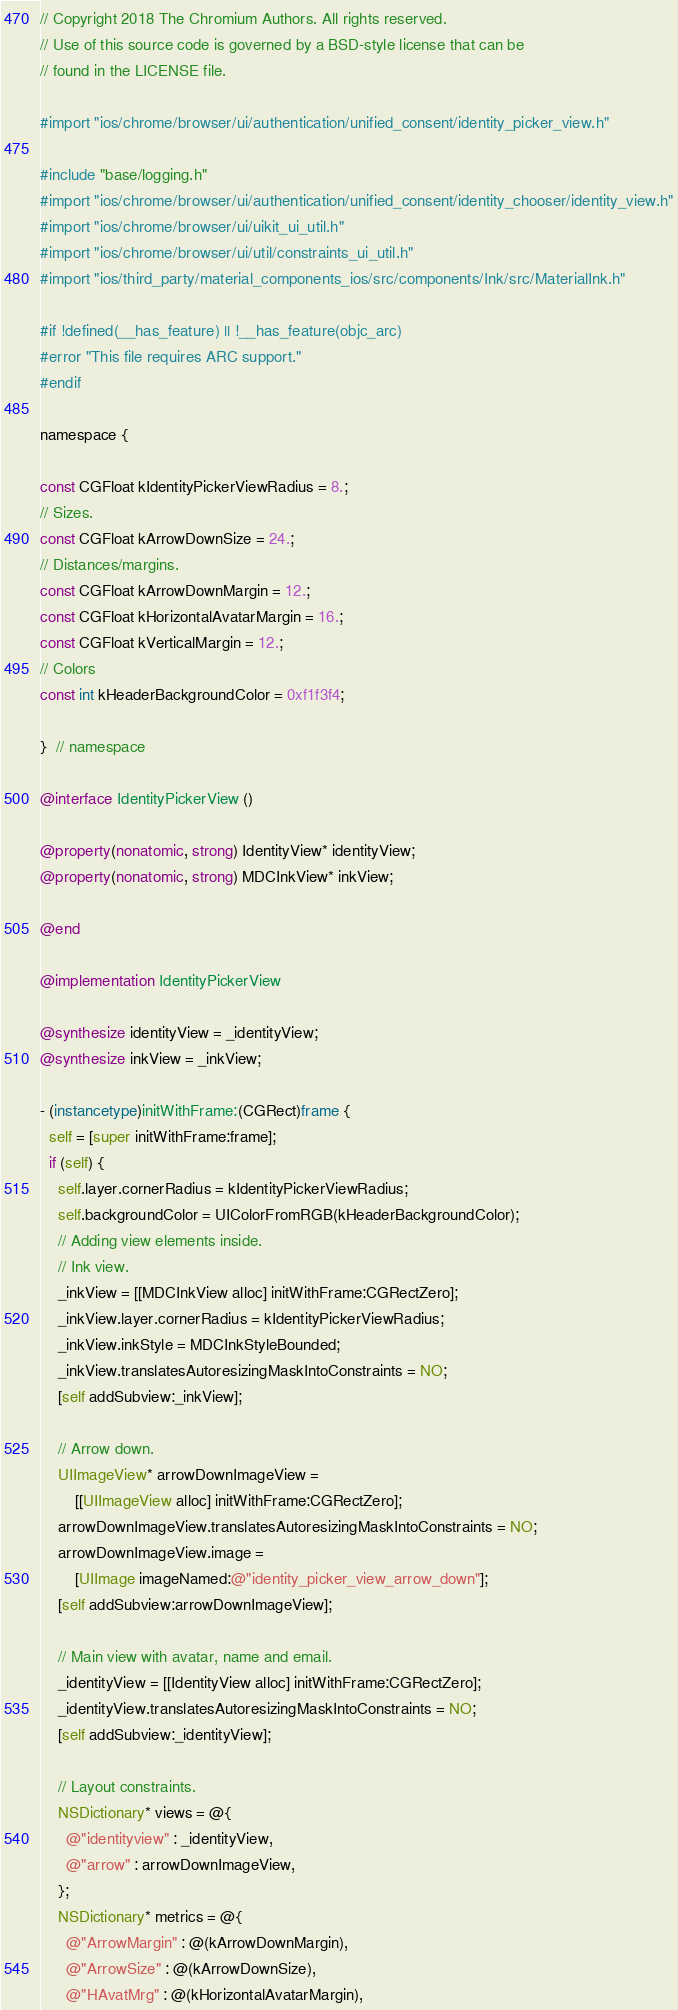<code> <loc_0><loc_0><loc_500><loc_500><_ObjectiveC_>// Copyright 2018 The Chromium Authors. All rights reserved.
// Use of this source code is governed by a BSD-style license that can be
// found in the LICENSE file.

#import "ios/chrome/browser/ui/authentication/unified_consent/identity_picker_view.h"

#include "base/logging.h"
#import "ios/chrome/browser/ui/authentication/unified_consent/identity_chooser/identity_view.h"
#import "ios/chrome/browser/ui/uikit_ui_util.h"
#import "ios/chrome/browser/ui/util/constraints_ui_util.h"
#import "ios/third_party/material_components_ios/src/components/Ink/src/MaterialInk.h"

#if !defined(__has_feature) || !__has_feature(objc_arc)
#error "This file requires ARC support."
#endif

namespace {

const CGFloat kIdentityPickerViewRadius = 8.;
// Sizes.
const CGFloat kArrowDownSize = 24.;
// Distances/margins.
const CGFloat kArrowDownMargin = 12.;
const CGFloat kHorizontalAvatarMargin = 16.;
const CGFloat kVerticalMargin = 12.;
// Colors
const int kHeaderBackgroundColor = 0xf1f3f4;

}  // namespace

@interface IdentityPickerView ()

@property(nonatomic, strong) IdentityView* identityView;
@property(nonatomic, strong) MDCInkView* inkView;

@end

@implementation IdentityPickerView

@synthesize identityView = _identityView;
@synthesize inkView = _inkView;

- (instancetype)initWithFrame:(CGRect)frame {
  self = [super initWithFrame:frame];
  if (self) {
    self.layer.cornerRadius = kIdentityPickerViewRadius;
    self.backgroundColor = UIColorFromRGB(kHeaderBackgroundColor);
    // Adding view elements inside.
    // Ink view.
    _inkView = [[MDCInkView alloc] initWithFrame:CGRectZero];
    _inkView.layer.cornerRadius = kIdentityPickerViewRadius;
    _inkView.inkStyle = MDCInkStyleBounded;
    _inkView.translatesAutoresizingMaskIntoConstraints = NO;
    [self addSubview:_inkView];

    // Arrow down.
    UIImageView* arrowDownImageView =
        [[UIImageView alloc] initWithFrame:CGRectZero];
    arrowDownImageView.translatesAutoresizingMaskIntoConstraints = NO;
    arrowDownImageView.image =
        [UIImage imageNamed:@"identity_picker_view_arrow_down"];
    [self addSubview:arrowDownImageView];

    // Main view with avatar, name and email.
    _identityView = [[IdentityView alloc] initWithFrame:CGRectZero];
    _identityView.translatesAutoresizingMaskIntoConstraints = NO;
    [self addSubview:_identityView];

    // Layout constraints.
    NSDictionary* views = @{
      @"identityview" : _identityView,
      @"arrow" : arrowDownImageView,
    };
    NSDictionary* metrics = @{
      @"ArrowMargin" : @(kArrowDownMargin),
      @"ArrowSize" : @(kArrowDownSize),
      @"HAvatMrg" : @(kHorizontalAvatarMargin),</code> 